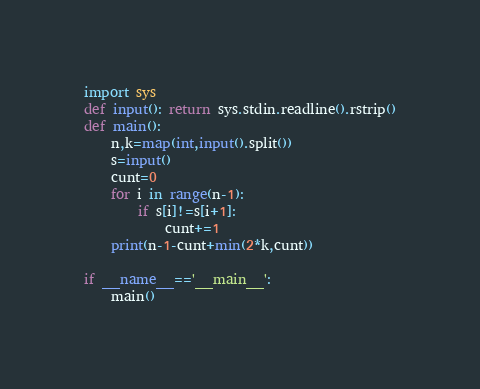Convert code to text. <code><loc_0><loc_0><loc_500><loc_500><_Python_>import sys
def input(): return sys.stdin.readline().rstrip()
def main():
    n,k=map(int,input().split())
    s=input()
    cunt=0
    for i in range(n-1):
        if s[i]!=s[i+1]:
            cunt+=1
    print(n-1-cunt+min(2*k,cunt))

if __name__=='__main__':
    main()</code> 